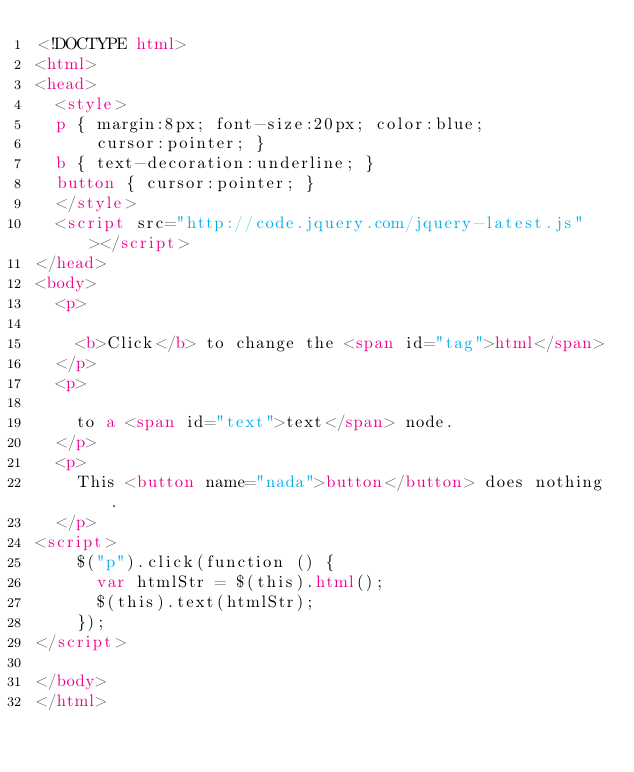Convert code to text. <code><loc_0><loc_0><loc_500><loc_500><_HTML_><!DOCTYPE html>
<html>
<head>
  <style>
  p { margin:8px; font-size:20px; color:blue;
      cursor:pointer; }
  b { text-decoration:underline; }
  button { cursor:pointer; }
  </style>
  <script src="http://code.jquery.com/jquery-latest.js"></script>
</head>
<body>
  <p>

    <b>Click</b> to change the <span id="tag">html</span>
  </p>
  <p>

    to a <span id="text">text</span> node.
  </p>
  <p>
    This <button name="nada">button</button> does nothing.
  </p>
<script>
    $("p").click(function () {
      var htmlStr = $(this).html();
      $(this).text(htmlStr);
    });
</script>

</body>
</html></code> 